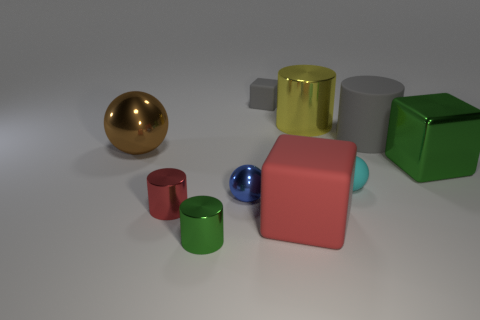Subtract all cylinders. How many objects are left? 6 Add 2 green metal objects. How many green metal objects exist? 4 Subtract 0 gray balls. How many objects are left? 10 Subtract all small rubber cubes. Subtract all large green metallic things. How many objects are left? 8 Add 1 small shiny cylinders. How many small shiny cylinders are left? 3 